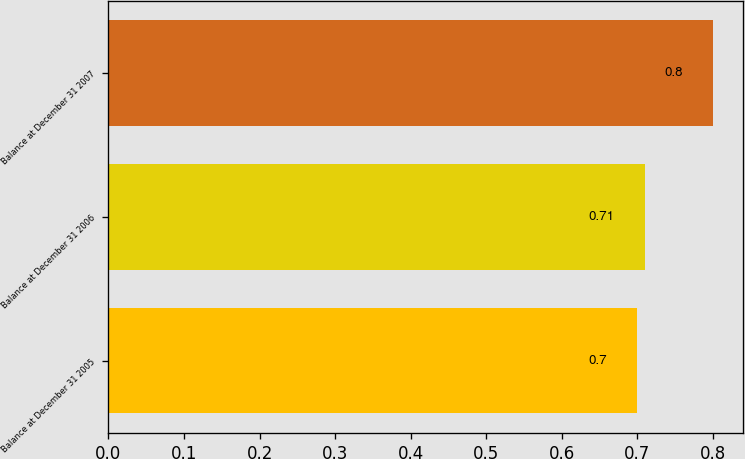<chart> <loc_0><loc_0><loc_500><loc_500><bar_chart><fcel>Balance at December 31 2005<fcel>Balance at December 31 2006<fcel>Balance at December 31 2007<nl><fcel>0.7<fcel>0.71<fcel>0.8<nl></chart> 